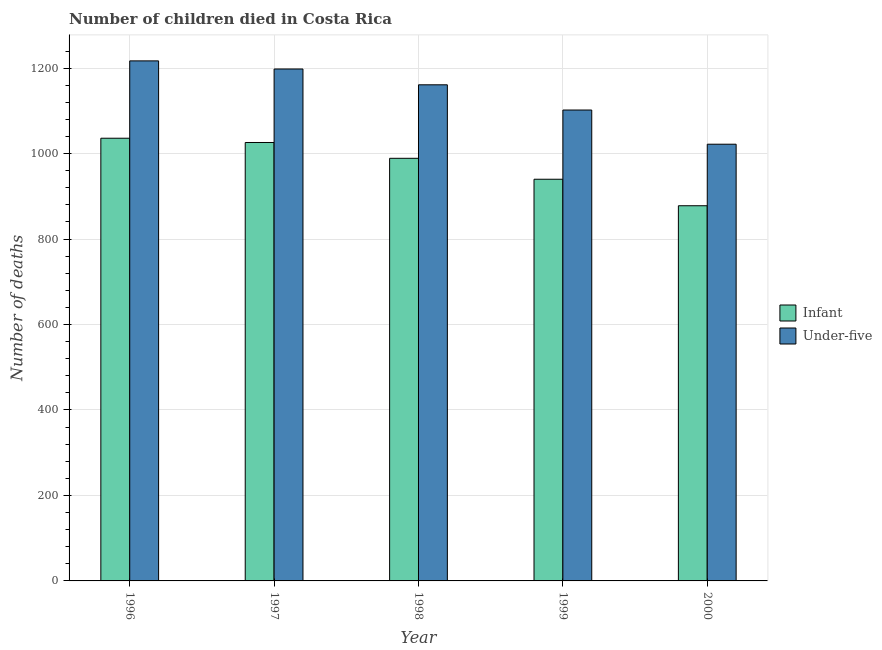How many different coloured bars are there?
Ensure brevity in your answer.  2. Are the number of bars on each tick of the X-axis equal?
Offer a very short reply. Yes. How many bars are there on the 5th tick from the right?
Your answer should be compact. 2. What is the number of under-five deaths in 1999?
Your answer should be compact. 1102. Across all years, what is the maximum number of under-five deaths?
Ensure brevity in your answer.  1217. Across all years, what is the minimum number of under-five deaths?
Keep it short and to the point. 1022. In which year was the number of under-five deaths maximum?
Provide a short and direct response. 1996. In which year was the number of under-five deaths minimum?
Keep it short and to the point. 2000. What is the total number of infant deaths in the graph?
Your answer should be compact. 4869. What is the difference between the number of under-five deaths in 1997 and that in 1998?
Give a very brief answer. 37. What is the difference between the number of infant deaths in 2000 and the number of under-five deaths in 1997?
Give a very brief answer. -148. What is the average number of infant deaths per year?
Your answer should be very brief. 973.8. In the year 1998, what is the difference between the number of under-five deaths and number of infant deaths?
Your answer should be compact. 0. What is the ratio of the number of infant deaths in 1997 to that in 1999?
Provide a short and direct response. 1.09. Is the number of under-five deaths in 1997 less than that in 1998?
Give a very brief answer. No. What is the difference between the highest and the lowest number of infant deaths?
Offer a very short reply. 158. In how many years, is the number of under-five deaths greater than the average number of under-five deaths taken over all years?
Make the answer very short. 3. What does the 1st bar from the left in 1997 represents?
Your answer should be compact. Infant. What does the 1st bar from the right in 1996 represents?
Provide a succinct answer. Under-five. What is the difference between two consecutive major ticks on the Y-axis?
Provide a short and direct response. 200. Are the values on the major ticks of Y-axis written in scientific E-notation?
Your response must be concise. No. Does the graph contain any zero values?
Offer a terse response. No. Where does the legend appear in the graph?
Your response must be concise. Center right. How many legend labels are there?
Provide a short and direct response. 2. What is the title of the graph?
Offer a very short reply. Number of children died in Costa Rica. Does "Female labor force" appear as one of the legend labels in the graph?
Keep it short and to the point. No. What is the label or title of the Y-axis?
Keep it short and to the point. Number of deaths. What is the Number of deaths in Infant in 1996?
Your response must be concise. 1036. What is the Number of deaths in Under-five in 1996?
Ensure brevity in your answer.  1217. What is the Number of deaths of Infant in 1997?
Give a very brief answer. 1026. What is the Number of deaths in Under-five in 1997?
Your answer should be compact. 1198. What is the Number of deaths of Infant in 1998?
Offer a terse response. 989. What is the Number of deaths of Under-five in 1998?
Ensure brevity in your answer.  1161. What is the Number of deaths in Infant in 1999?
Your response must be concise. 940. What is the Number of deaths of Under-five in 1999?
Your response must be concise. 1102. What is the Number of deaths in Infant in 2000?
Your answer should be very brief. 878. What is the Number of deaths in Under-five in 2000?
Your response must be concise. 1022. Across all years, what is the maximum Number of deaths in Infant?
Your answer should be compact. 1036. Across all years, what is the maximum Number of deaths in Under-five?
Your response must be concise. 1217. Across all years, what is the minimum Number of deaths of Infant?
Offer a terse response. 878. Across all years, what is the minimum Number of deaths of Under-five?
Ensure brevity in your answer.  1022. What is the total Number of deaths of Infant in the graph?
Keep it short and to the point. 4869. What is the total Number of deaths in Under-five in the graph?
Offer a very short reply. 5700. What is the difference between the Number of deaths in Under-five in 1996 and that in 1997?
Provide a succinct answer. 19. What is the difference between the Number of deaths in Infant in 1996 and that in 1999?
Ensure brevity in your answer.  96. What is the difference between the Number of deaths in Under-five in 1996 and that in 1999?
Provide a succinct answer. 115. What is the difference between the Number of deaths of Infant in 1996 and that in 2000?
Give a very brief answer. 158. What is the difference between the Number of deaths in Under-five in 1996 and that in 2000?
Give a very brief answer. 195. What is the difference between the Number of deaths in Infant in 1997 and that in 1999?
Keep it short and to the point. 86. What is the difference between the Number of deaths in Under-five in 1997 and that in 1999?
Make the answer very short. 96. What is the difference between the Number of deaths in Infant in 1997 and that in 2000?
Provide a short and direct response. 148. What is the difference between the Number of deaths of Under-five in 1997 and that in 2000?
Your answer should be very brief. 176. What is the difference between the Number of deaths of Infant in 1998 and that in 2000?
Your answer should be compact. 111. What is the difference between the Number of deaths in Under-five in 1998 and that in 2000?
Ensure brevity in your answer.  139. What is the difference between the Number of deaths of Under-five in 1999 and that in 2000?
Your answer should be very brief. 80. What is the difference between the Number of deaths in Infant in 1996 and the Number of deaths in Under-five in 1997?
Give a very brief answer. -162. What is the difference between the Number of deaths in Infant in 1996 and the Number of deaths in Under-five in 1998?
Provide a short and direct response. -125. What is the difference between the Number of deaths in Infant in 1996 and the Number of deaths in Under-five in 1999?
Your response must be concise. -66. What is the difference between the Number of deaths of Infant in 1996 and the Number of deaths of Under-five in 2000?
Provide a succinct answer. 14. What is the difference between the Number of deaths in Infant in 1997 and the Number of deaths in Under-five in 1998?
Keep it short and to the point. -135. What is the difference between the Number of deaths in Infant in 1997 and the Number of deaths in Under-five in 1999?
Offer a terse response. -76. What is the difference between the Number of deaths of Infant in 1997 and the Number of deaths of Under-five in 2000?
Make the answer very short. 4. What is the difference between the Number of deaths in Infant in 1998 and the Number of deaths in Under-five in 1999?
Your response must be concise. -113. What is the difference between the Number of deaths of Infant in 1998 and the Number of deaths of Under-five in 2000?
Provide a succinct answer. -33. What is the difference between the Number of deaths of Infant in 1999 and the Number of deaths of Under-five in 2000?
Give a very brief answer. -82. What is the average Number of deaths in Infant per year?
Provide a short and direct response. 973.8. What is the average Number of deaths in Under-five per year?
Offer a very short reply. 1140. In the year 1996, what is the difference between the Number of deaths in Infant and Number of deaths in Under-five?
Your answer should be very brief. -181. In the year 1997, what is the difference between the Number of deaths of Infant and Number of deaths of Under-five?
Your answer should be compact. -172. In the year 1998, what is the difference between the Number of deaths of Infant and Number of deaths of Under-five?
Offer a very short reply. -172. In the year 1999, what is the difference between the Number of deaths in Infant and Number of deaths in Under-five?
Your response must be concise. -162. In the year 2000, what is the difference between the Number of deaths of Infant and Number of deaths of Under-five?
Give a very brief answer. -144. What is the ratio of the Number of deaths of Infant in 1996 to that in 1997?
Provide a succinct answer. 1.01. What is the ratio of the Number of deaths of Under-five in 1996 to that in 1997?
Keep it short and to the point. 1.02. What is the ratio of the Number of deaths in Infant in 1996 to that in 1998?
Your response must be concise. 1.05. What is the ratio of the Number of deaths in Under-five in 1996 to that in 1998?
Your answer should be very brief. 1.05. What is the ratio of the Number of deaths of Infant in 1996 to that in 1999?
Provide a short and direct response. 1.1. What is the ratio of the Number of deaths of Under-five in 1996 to that in 1999?
Your answer should be very brief. 1.1. What is the ratio of the Number of deaths of Infant in 1996 to that in 2000?
Your response must be concise. 1.18. What is the ratio of the Number of deaths of Under-five in 1996 to that in 2000?
Your response must be concise. 1.19. What is the ratio of the Number of deaths of Infant in 1997 to that in 1998?
Your answer should be very brief. 1.04. What is the ratio of the Number of deaths of Under-five in 1997 to that in 1998?
Give a very brief answer. 1.03. What is the ratio of the Number of deaths of Infant in 1997 to that in 1999?
Keep it short and to the point. 1.09. What is the ratio of the Number of deaths in Under-five in 1997 to that in 1999?
Offer a terse response. 1.09. What is the ratio of the Number of deaths in Infant in 1997 to that in 2000?
Give a very brief answer. 1.17. What is the ratio of the Number of deaths in Under-five in 1997 to that in 2000?
Your answer should be compact. 1.17. What is the ratio of the Number of deaths of Infant in 1998 to that in 1999?
Provide a short and direct response. 1.05. What is the ratio of the Number of deaths of Under-five in 1998 to that in 1999?
Offer a terse response. 1.05. What is the ratio of the Number of deaths of Infant in 1998 to that in 2000?
Make the answer very short. 1.13. What is the ratio of the Number of deaths of Under-five in 1998 to that in 2000?
Ensure brevity in your answer.  1.14. What is the ratio of the Number of deaths in Infant in 1999 to that in 2000?
Your answer should be very brief. 1.07. What is the ratio of the Number of deaths in Under-five in 1999 to that in 2000?
Give a very brief answer. 1.08. What is the difference between the highest and the second highest Number of deaths in Under-five?
Provide a short and direct response. 19. What is the difference between the highest and the lowest Number of deaths of Infant?
Ensure brevity in your answer.  158. What is the difference between the highest and the lowest Number of deaths in Under-five?
Give a very brief answer. 195. 